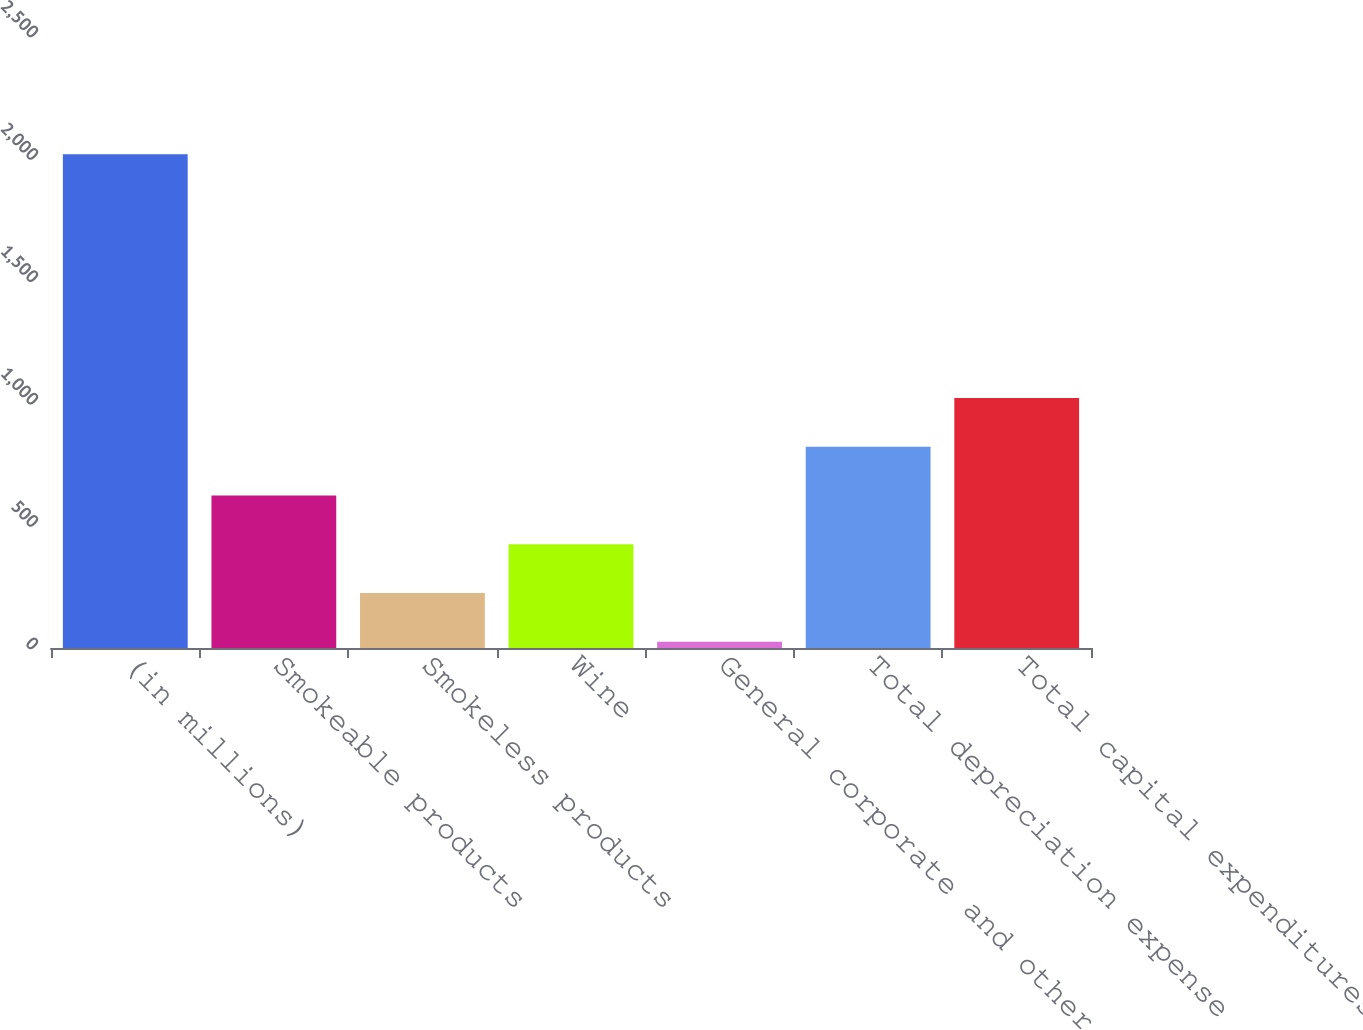Convert chart to OTSL. <chart><loc_0><loc_0><loc_500><loc_500><bar_chart><fcel>(in millions)<fcel>Smokeable products<fcel>Smokeless products<fcel>Wine<fcel>General corporate and other<fcel>Total depreciation expense<fcel>Total capital expenditures<nl><fcel>2017<fcel>623.3<fcel>225.1<fcel>424.2<fcel>26<fcel>822.4<fcel>1021.5<nl></chart> 